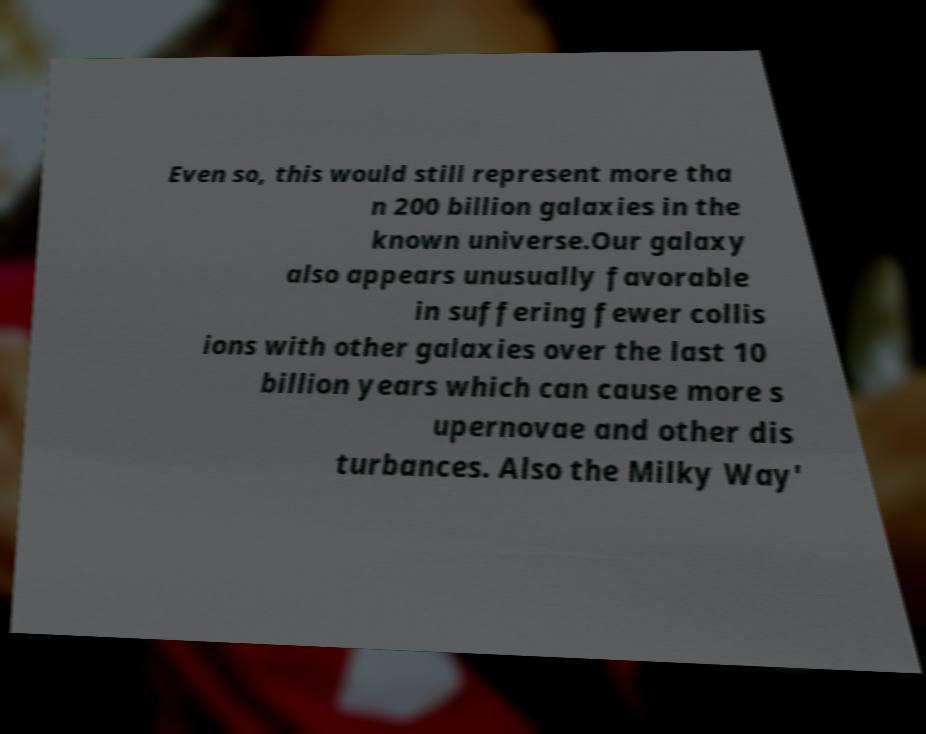There's text embedded in this image that I need extracted. Can you transcribe it verbatim? Even so, this would still represent more tha n 200 billion galaxies in the known universe.Our galaxy also appears unusually favorable in suffering fewer collis ions with other galaxies over the last 10 billion years which can cause more s upernovae and other dis turbances. Also the Milky Way' 